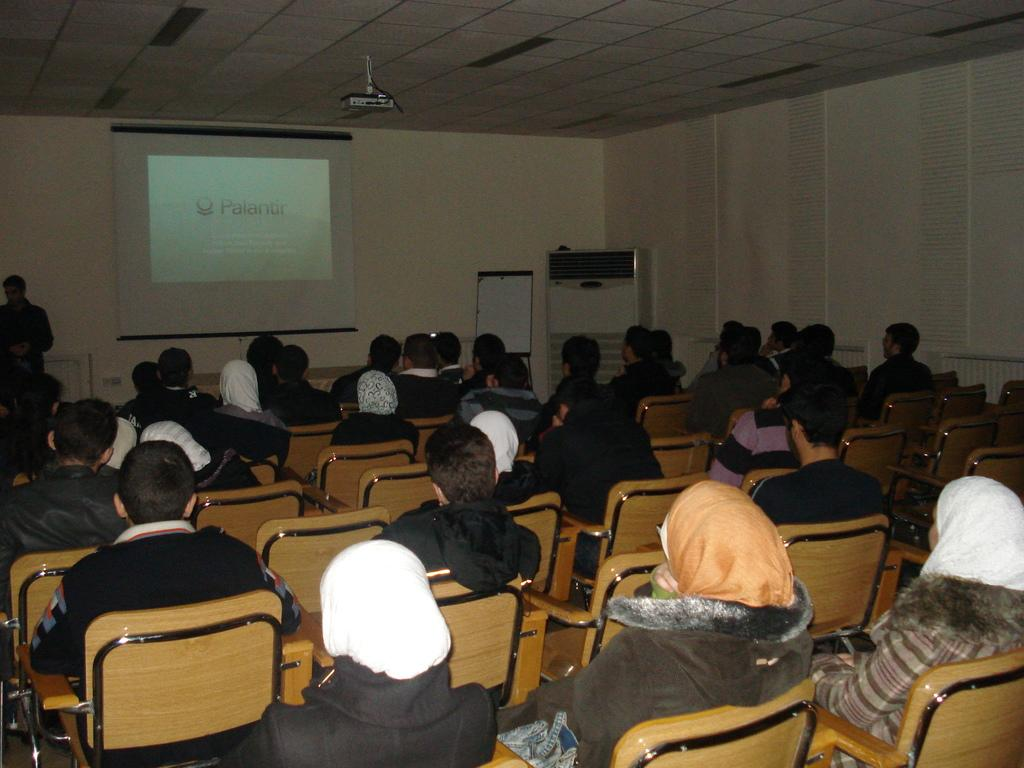How many people are in the image? There is a group of people in the image. What are the people doing in the image? The people are sitting in chairs. Is there anyone standing in the image? Yes, there is a person standing on the left side of the image. What can be seen in the background of the image? In the background, there is a projector, a board, and a curtain. What type of mitten is being used to clean the soap off the board in the image? There is no mitten or soap present in the image. How many people are sleeping in the image? There are no people sleeping in the image; the people are sitting or standing. 